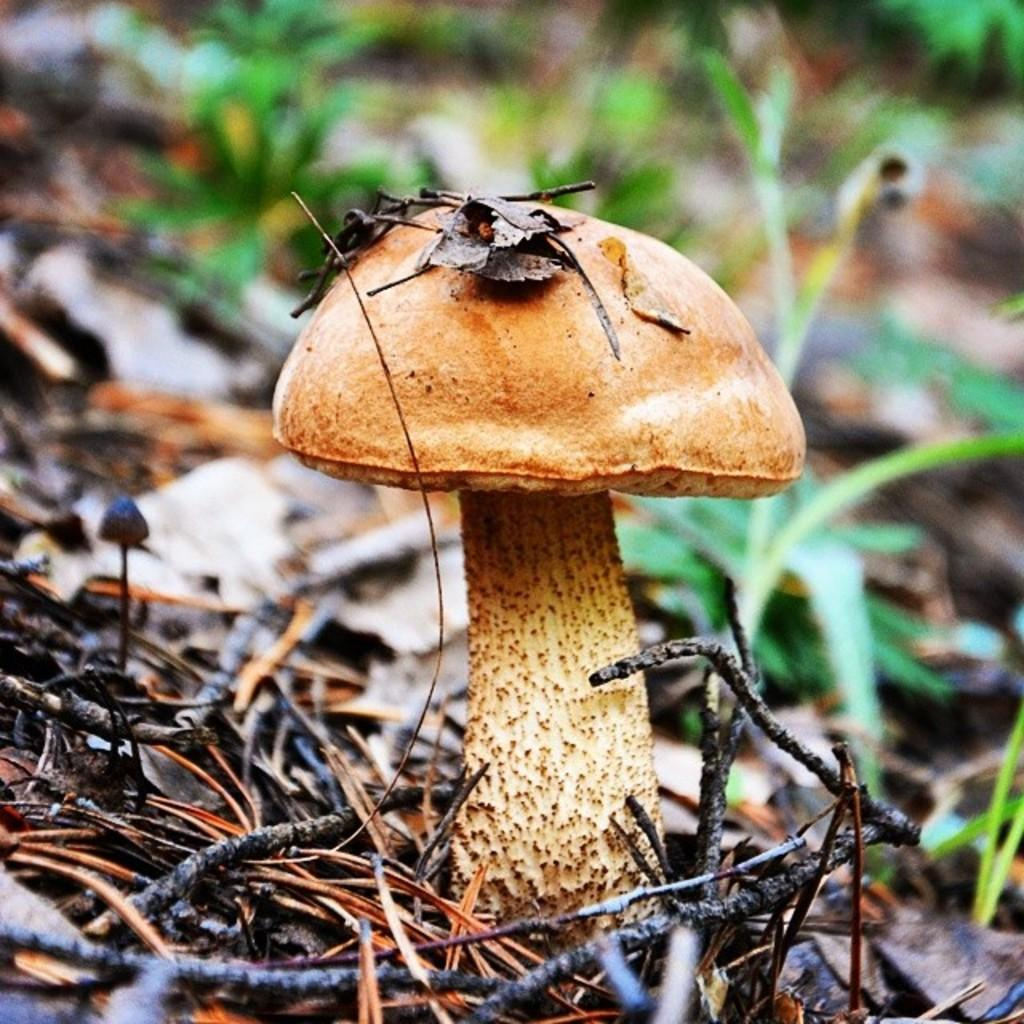What is the main subject of the picture? The main subject of the picture is a mushroom. What can be seen in the background of the picture? There are green leaves in the background of the picture. What type of theory can be seen being developed by the mushroom in the image? There is no indication of a theory being developed in the image, as it features a mushroom and green leaves. What type of toys can be seen in the image? There are no toys present in the image. 